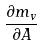Convert formula to latex. <formula><loc_0><loc_0><loc_500><loc_500>\frac { \partial m _ { v } } { \partial A }</formula> 